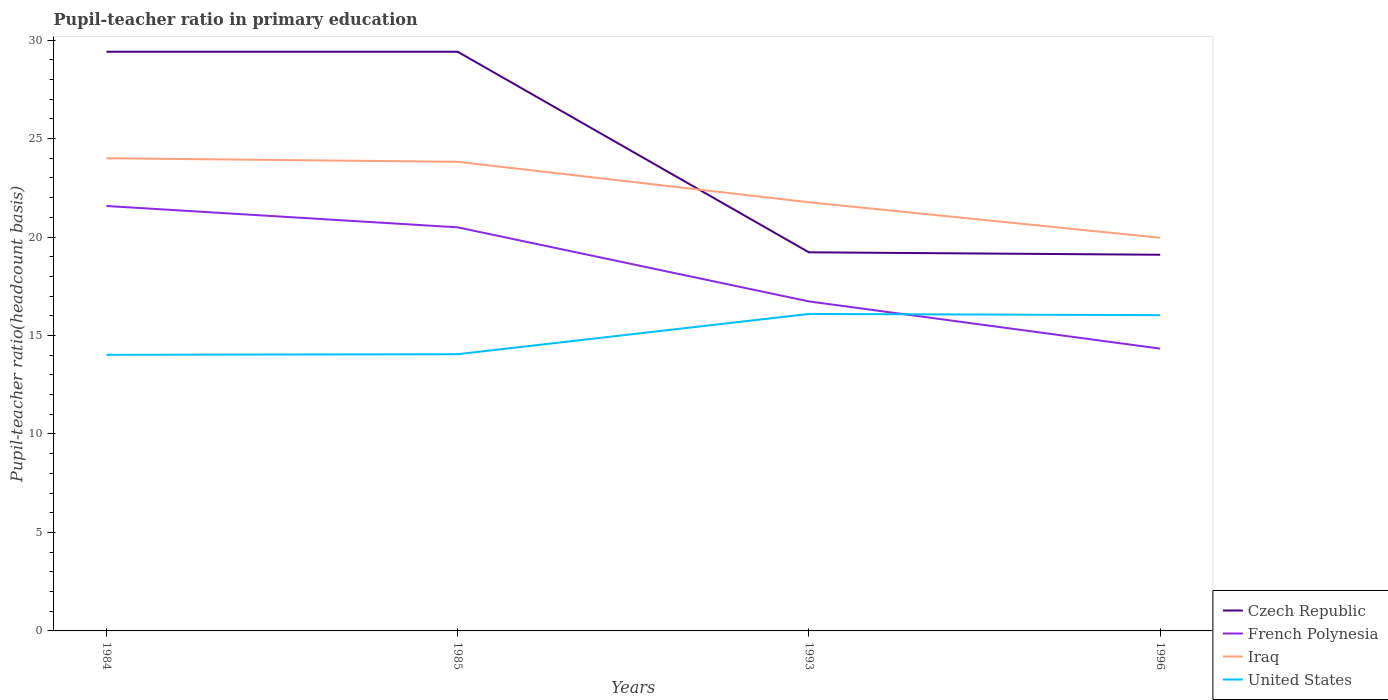Does the line corresponding to French Polynesia intersect with the line corresponding to Iraq?
Provide a short and direct response. No. Across all years, what is the maximum pupil-teacher ratio in primary education in United States?
Offer a very short reply. 14.02. What is the total pupil-teacher ratio in primary education in French Polynesia in the graph?
Offer a very short reply. 7.24. What is the difference between the highest and the second highest pupil-teacher ratio in primary education in Czech Republic?
Ensure brevity in your answer.  10.31. What is the difference between the highest and the lowest pupil-teacher ratio in primary education in United States?
Keep it short and to the point. 2. How many lines are there?
Provide a succinct answer. 4. How many years are there in the graph?
Give a very brief answer. 4. What is the difference between two consecutive major ticks on the Y-axis?
Provide a short and direct response. 5. Are the values on the major ticks of Y-axis written in scientific E-notation?
Your answer should be compact. No. Does the graph contain any zero values?
Offer a very short reply. No. Where does the legend appear in the graph?
Your response must be concise. Bottom right. What is the title of the graph?
Provide a succinct answer. Pupil-teacher ratio in primary education. Does "China" appear as one of the legend labels in the graph?
Your answer should be compact. No. What is the label or title of the X-axis?
Make the answer very short. Years. What is the label or title of the Y-axis?
Provide a succinct answer. Pupil-teacher ratio(headcount basis). What is the Pupil-teacher ratio(headcount basis) of Czech Republic in 1984?
Your answer should be compact. 29.41. What is the Pupil-teacher ratio(headcount basis) of French Polynesia in 1984?
Provide a succinct answer. 21.58. What is the Pupil-teacher ratio(headcount basis) of Iraq in 1984?
Make the answer very short. 24. What is the Pupil-teacher ratio(headcount basis) in United States in 1984?
Offer a terse response. 14.02. What is the Pupil-teacher ratio(headcount basis) of Czech Republic in 1985?
Make the answer very short. 29.41. What is the Pupil-teacher ratio(headcount basis) of French Polynesia in 1985?
Provide a succinct answer. 20.49. What is the Pupil-teacher ratio(headcount basis) of Iraq in 1985?
Give a very brief answer. 23.82. What is the Pupil-teacher ratio(headcount basis) of United States in 1985?
Your response must be concise. 14.05. What is the Pupil-teacher ratio(headcount basis) of Czech Republic in 1993?
Offer a very short reply. 19.23. What is the Pupil-teacher ratio(headcount basis) of French Polynesia in 1993?
Offer a very short reply. 16.73. What is the Pupil-teacher ratio(headcount basis) in Iraq in 1993?
Ensure brevity in your answer.  21.77. What is the Pupil-teacher ratio(headcount basis) of United States in 1993?
Offer a very short reply. 16.1. What is the Pupil-teacher ratio(headcount basis) in Czech Republic in 1996?
Give a very brief answer. 19.1. What is the Pupil-teacher ratio(headcount basis) in French Polynesia in 1996?
Your answer should be compact. 14.33. What is the Pupil-teacher ratio(headcount basis) in Iraq in 1996?
Your response must be concise. 19.96. What is the Pupil-teacher ratio(headcount basis) of United States in 1996?
Make the answer very short. 16.03. Across all years, what is the maximum Pupil-teacher ratio(headcount basis) of Czech Republic?
Ensure brevity in your answer.  29.41. Across all years, what is the maximum Pupil-teacher ratio(headcount basis) of French Polynesia?
Make the answer very short. 21.58. Across all years, what is the maximum Pupil-teacher ratio(headcount basis) in Iraq?
Your response must be concise. 24. Across all years, what is the maximum Pupil-teacher ratio(headcount basis) in United States?
Make the answer very short. 16.1. Across all years, what is the minimum Pupil-teacher ratio(headcount basis) in Czech Republic?
Provide a succinct answer. 19.1. Across all years, what is the minimum Pupil-teacher ratio(headcount basis) of French Polynesia?
Ensure brevity in your answer.  14.33. Across all years, what is the minimum Pupil-teacher ratio(headcount basis) in Iraq?
Your answer should be compact. 19.96. Across all years, what is the minimum Pupil-teacher ratio(headcount basis) of United States?
Ensure brevity in your answer.  14.02. What is the total Pupil-teacher ratio(headcount basis) of Czech Republic in the graph?
Ensure brevity in your answer.  97.15. What is the total Pupil-teacher ratio(headcount basis) of French Polynesia in the graph?
Your response must be concise. 73.14. What is the total Pupil-teacher ratio(headcount basis) in Iraq in the graph?
Your response must be concise. 89.56. What is the total Pupil-teacher ratio(headcount basis) in United States in the graph?
Your answer should be very brief. 60.2. What is the difference between the Pupil-teacher ratio(headcount basis) of Czech Republic in 1984 and that in 1985?
Provide a short and direct response. 0. What is the difference between the Pupil-teacher ratio(headcount basis) in French Polynesia in 1984 and that in 1985?
Ensure brevity in your answer.  1.08. What is the difference between the Pupil-teacher ratio(headcount basis) of Iraq in 1984 and that in 1985?
Your answer should be very brief. 0.18. What is the difference between the Pupil-teacher ratio(headcount basis) of United States in 1984 and that in 1985?
Make the answer very short. -0.03. What is the difference between the Pupil-teacher ratio(headcount basis) in Czech Republic in 1984 and that in 1993?
Keep it short and to the point. 10.19. What is the difference between the Pupil-teacher ratio(headcount basis) in French Polynesia in 1984 and that in 1993?
Ensure brevity in your answer.  4.85. What is the difference between the Pupil-teacher ratio(headcount basis) of Iraq in 1984 and that in 1993?
Keep it short and to the point. 2.23. What is the difference between the Pupil-teacher ratio(headcount basis) in United States in 1984 and that in 1993?
Ensure brevity in your answer.  -2.08. What is the difference between the Pupil-teacher ratio(headcount basis) in Czech Republic in 1984 and that in 1996?
Your answer should be compact. 10.31. What is the difference between the Pupil-teacher ratio(headcount basis) in French Polynesia in 1984 and that in 1996?
Keep it short and to the point. 7.24. What is the difference between the Pupil-teacher ratio(headcount basis) of Iraq in 1984 and that in 1996?
Offer a very short reply. 4.04. What is the difference between the Pupil-teacher ratio(headcount basis) of United States in 1984 and that in 1996?
Give a very brief answer. -2.01. What is the difference between the Pupil-teacher ratio(headcount basis) of Czech Republic in 1985 and that in 1993?
Your answer should be very brief. 10.19. What is the difference between the Pupil-teacher ratio(headcount basis) of French Polynesia in 1985 and that in 1993?
Ensure brevity in your answer.  3.76. What is the difference between the Pupil-teacher ratio(headcount basis) of Iraq in 1985 and that in 1993?
Your response must be concise. 2.05. What is the difference between the Pupil-teacher ratio(headcount basis) in United States in 1985 and that in 1993?
Your response must be concise. -2.05. What is the difference between the Pupil-teacher ratio(headcount basis) of Czech Republic in 1985 and that in 1996?
Keep it short and to the point. 10.31. What is the difference between the Pupil-teacher ratio(headcount basis) in French Polynesia in 1985 and that in 1996?
Provide a succinct answer. 6.16. What is the difference between the Pupil-teacher ratio(headcount basis) of Iraq in 1985 and that in 1996?
Keep it short and to the point. 3.86. What is the difference between the Pupil-teacher ratio(headcount basis) of United States in 1985 and that in 1996?
Make the answer very short. -1.98. What is the difference between the Pupil-teacher ratio(headcount basis) in Czech Republic in 1993 and that in 1996?
Your response must be concise. 0.12. What is the difference between the Pupil-teacher ratio(headcount basis) of French Polynesia in 1993 and that in 1996?
Your answer should be very brief. 2.4. What is the difference between the Pupil-teacher ratio(headcount basis) in Iraq in 1993 and that in 1996?
Provide a short and direct response. 1.8. What is the difference between the Pupil-teacher ratio(headcount basis) in United States in 1993 and that in 1996?
Provide a succinct answer. 0.06. What is the difference between the Pupil-teacher ratio(headcount basis) in Czech Republic in 1984 and the Pupil-teacher ratio(headcount basis) in French Polynesia in 1985?
Your response must be concise. 8.92. What is the difference between the Pupil-teacher ratio(headcount basis) of Czech Republic in 1984 and the Pupil-teacher ratio(headcount basis) of Iraq in 1985?
Your answer should be compact. 5.59. What is the difference between the Pupil-teacher ratio(headcount basis) of Czech Republic in 1984 and the Pupil-teacher ratio(headcount basis) of United States in 1985?
Provide a short and direct response. 15.36. What is the difference between the Pupil-teacher ratio(headcount basis) in French Polynesia in 1984 and the Pupil-teacher ratio(headcount basis) in Iraq in 1985?
Make the answer very short. -2.24. What is the difference between the Pupil-teacher ratio(headcount basis) in French Polynesia in 1984 and the Pupil-teacher ratio(headcount basis) in United States in 1985?
Provide a succinct answer. 7.53. What is the difference between the Pupil-teacher ratio(headcount basis) of Iraq in 1984 and the Pupil-teacher ratio(headcount basis) of United States in 1985?
Provide a succinct answer. 9.95. What is the difference between the Pupil-teacher ratio(headcount basis) of Czech Republic in 1984 and the Pupil-teacher ratio(headcount basis) of French Polynesia in 1993?
Give a very brief answer. 12.68. What is the difference between the Pupil-teacher ratio(headcount basis) of Czech Republic in 1984 and the Pupil-teacher ratio(headcount basis) of Iraq in 1993?
Ensure brevity in your answer.  7.64. What is the difference between the Pupil-teacher ratio(headcount basis) of Czech Republic in 1984 and the Pupil-teacher ratio(headcount basis) of United States in 1993?
Offer a terse response. 13.32. What is the difference between the Pupil-teacher ratio(headcount basis) in French Polynesia in 1984 and the Pupil-teacher ratio(headcount basis) in Iraq in 1993?
Make the answer very short. -0.19. What is the difference between the Pupil-teacher ratio(headcount basis) of French Polynesia in 1984 and the Pupil-teacher ratio(headcount basis) of United States in 1993?
Your answer should be very brief. 5.48. What is the difference between the Pupil-teacher ratio(headcount basis) in Iraq in 1984 and the Pupil-teacher ratio(headcount basis) in United States in 1993?
Offer a very short reply. 7.91. What is the difference between the Pupil-teacher ratio(headcount basis) of Czech Republic in 1984 and the Pupil-teacher ratio(headcount basis) of French Polynesia in 1996?
Keep it short and to the point. 15.08. What is the difference between the Pupil-teacher ratio(headcount basis) in Czech Republic in 1984 and the Pupil-teacher ratio(headcount basis) in Iraq in 1996?
Make the answer very short. 9.45. What is the difference between the Pupil-teacher ratio(headcount basis) of Czech Republic in 1984 and the Pupil-teacher ratio(headcount basis) of United States in 1996?
Offer a terse response. 13.38. What is the difference between the Pupil-teacher ratio(headcount basis) of French Polynesia in 1984 and the Pupil-teacher ratio(headcount basis) of Iraq in 1996?
Your answer should be compact. 1.61. What is the difference between the Pupil-teacher ratio(headcount basis) in French Polynesia in 1984 and the Pupil-teacher ratio(headcount basis) in United States in 1996?
Make the answer very short. 5.54. What is the difference between the Pupil-teacher ratio(headcount basis) in Iraq in 1984 and the Pupil-teacher ratio(headcount basis) in United States in 1996?
Offer a terse response. 7.97. What is the difference between the Pupil-teacher ratio(headcount basis) in Czech Republic in 1985 and the Pupil-teacher ratio(headcount basis) in French Polynesia in 1993?
Your answer should be compact. 12.68. What is the difference between the Pupil-teacher ratio(headcount basis) in Czech Republic in 1985 and the Pupil-teacher ratio(headcount basis) in Iraq in 1993?
Ensure brevity in your answer.  7.64. What is the difference between the Pupil-teacher ratio(headcount basis) of Czech Republic in 1985 and the Pupil-teacher ratio(headcount basis) of United States in 1993?
Keep it short and to the point. 13.31. What is the difference between the Pupil-teacher ratio(headcount basis) in French Polynesia in 1985 and the Pupil-teacher ratio(headcount basis) in Iraq in 1993?
Ensure brevity in your answer.  -1.27. What is the difference between the Pupil-teacher ratio(headcount basis) in French Polynesia in 1985 and the Pupil-teacher ratio(headcount basis) in United States in 1993?
Provide a succinct answer. 4.4. What is the difference between the Pupil-teacher ratio(headcount basis) in Iraq in 1985 and the Pupil-teacher ratio(headcount basis) in United States in 1993?
Provide a short and direct response. 7.73. What is the difference between the Pupil-teacher ratio(headcount basis) of Czech Republic in 1985 and the Pupil-teacher ratio(headcount basis) of French Polynesia in 1996?
Keep it short and to the point. 15.08. What is the difference between the Pupil-teacher ratio(headcount basis) of Czech Republic in 1985 and the Pupil-teacher ratio(headcount basis) of Iraq in 1996?
Ensure brevity in your answer.  9.45. What is the difference between the Pupil-teacher ratio(headcount basis) of Czech Republic in 1985 and the Pupil-teacher ratio(headcount basis) of United States in 1996?
Your answer should be compact. 13.38. What is the difference between the Pupil-teacher ratio(headcount basis) of French Polynesia in 1985 and the Pupil-teacher ratio(headcount basis) of Iraq in 1996?
Ensure brevity in your answer.  0.53. What is the difference between the Pupil-teacher ratio(headcount basis) of French Polynesia in 1985 and the Pupil-teacher ratio(headcount basis) of United States in 1996?
Make the answer very short. 4.46. What is the difference between the Pupil-teacher ratio(headcount basis) of Iraq in 1985 and the Pupil-teacher ratio(headcount basis) of United States in 1996?
Your answer should be compact. 7.79. What is the difference between the Pupil-teacher ratio(headcount basis) in Czech Republic in 1993 and the Pupil-teacher ratio(headcount basis) in French Polynesia in 1996?
Your answer should be compact. 4.89. What is the difference between the Pupil-teacher ratio(headcount basis) of Czech Republic in 1993 and the Pupil-teacher ratio(headcount basis) of Iraq in 1996?
Provide a short and direct response. -0.74. What is the difference between the Pupil-teacher ratio(headcount basis) in Czech Republic in 1993 and the Pupil-teacher ratio(headcount basis) in United States in 1996?
Provide a succinct answer. 3.19. What is the difference between the Pupil-teacher ratio(headcount basis) of French Polynesia in 1993 and the Pupil-teacher ratio(headcount basis) of Iraq in 1996?
Provide a short and direct response. -3.23. What is the difference between the Pupil-teacher ratio(headcount basis) in French Polynesia in 1993 and the Pupil-teacher ratio(headcount basis) in United States in 1996?
Provide a short and direct response. 0.7. What is the difference between the Pupil-teacher ratio(headcount basis) in Iraq in 1993 and the Pupil-teacher ratio(headcount basis) in United States in 1996?
Your response must be concise. 5.73. What is the average Pupil-teacher ratio(headcount basis) in Czech Republic per year?
Ensure brevity in your answer.  24.29. What is the average Pupil-teacher ratio(headcount basis) in French Polynesia per year?
Give a very brief answer. 18.29. What is the average Pupil-teacher ratio(headcount basis) in Iraq per year?
Your answer should be compact. 22.39. What is the average Pupil-teacher ratio(headcount basis) of United States per year?
Keep it short and to the point. 15.05. In the year 1984, what is the difference between the Pupil-teacher ratio(headcount basis) in Czech Republic and Pupil-teacher ratio(headcount basis) in French Polynesia?
Your answer should be compact. 7.83. In the year 1984, what is the difference between the Pupil-teacher ratio(headcount basis) of Czech Republic and Pupil-teacher ratio(headcount basis) of Iraq?
Offer a very short reply. 5.41. In the year 1984, what is the difference between the Pupil-teacher ratio(headcount basis) in Czech Republic and Pupil-teacher ratio(headcount basis) in United States?
Keep it short and to the point. 15.39. In the year 1984, what is the difference between the Pupil-teacher ratio(headcount basis) in French Polynesia and Pupil-teacher ratio(headcount basis) in Iraq?
Give a very brief answer. -2.42. In the year 1984, what is the difference between the Pupil-teacher ratio(headcount basis) in French Polynesia and Pupil-teacher ratio(headcount basis) in United States?
Your answer should be very brief. 7.56. In the year 1984, what is the difference between the Pupil-teacher ratio(headcount basis) in Iraq and Pupil-teacher ratio(headcount basis) in United States?
Offer a terse response. 9.98. In the year 1985, what is the difference between the Pupil-teacher ratio(headcount basis) of Czech Republic and Pupil-teacher ratio(headcount basis) of French Polynesia?
Provide a succinct answer. 8.92. In the year 1985, what is the difference between the Pupil-teacher ratio(headcount basis) in Czech Republic and Pupil-teacher ratio(headcount basis) in Iraq?
Offer a very short reply. 5.59. In the year 1985, what is the difference between the Pupil-teacher ratio(headcount basis) of Czech Republic and Pupil-teacher ratio(headcount basis) of United States?
Make the answer very short. 15.36. In the year 1985, what is the difference between the Pupil-teacher ratio(headcount basis) of French Polynesia and Pupil-teacher ratio(headcount basis) of Iraq?
Your answer should be compact. -3.33. In the year 1985, what is the difference between the Pupil-teacher ratio(headcount basis) in French Polynesia and Pupil-teacher ratio(headcount basis) in United States?
Give a very brief answer. 6.44. In the year 1985, what is the difference between the Pupil-teacher ratio(headcount basis) of Iraq and Pupil-teacher ratio(headcount basis) of United States?
Your answer should be very brief. 9.77. In the year 1993, what is the difference between the Pupil-teacher ratio(headcount basis) of Czech Republic and Pupil-teacher ratio(headcount basis) of French Polynesia?
Your response must be concise. 2.49. In the year 1993, what is the difference between the Pupil-teacher ratio(headcount basis) in Czech Republic and Pupil-teacher ratio(headcount basis) in Iraq?
Give a very brief answer. -2.54. In the year 1993, what is the difference between the Pupil-teacher ratio(headcount basis) in Czech Republic and Pupil-teacher ratio(headcount basis) in United States?
Provide a short and direct response. 3.13. In the year 1993, what is the difference between the Pupil-teacher ratio(headcount basis) of French Polynesia and Pupil-teacher ratio(headcount basis) of Iraq?
Keep it short and to the point. -5.03. In the year 1993, what is the difference between the Pupil-teacher ratio(headcount basis) of French Polynesia and Pupil-teacher ratio(headcount basis) of United States?
Your answer should be compact. 0.64. In the year 1993, what is the difference between the Pupil-teacher ratio(headcount basis) of Iraq and Pupil-teacher ratio(headcount basis) of United States?
Ensure brevity in your answer.  5.67. In the year 1996, what is the difference between the Pupil-teacher ratio(headcount basis) in Czech Republic and Pupil-teacher ratio(headcount basis) in French Polynesia?
Keep it short and to the point. 4.77. In the year 1996, what is the difference between the Pupil-teacher ratio(headcount basis) of Czech Republic and Pupil-teacher ratio(headcount basis) of Iraq?
Make the answer very short. -0.86. In the year 1996, what is the difference between the Pupil-teacher ratio(headcount basis) of Czech Republic and Pupil-teacher ratio(headcount basis) of United States?
Your answer should be compact. 3.07. In the year 1996, what is the difference between the Pupil-teacher ratio(headcount basis) of French Polynesia and Pupil-teacher ratio(headcount basis) of Iraq?
Make the answer very short. -5.63. In the year 1996, what is the difference between the Pupil-teacher ratio(headcount basis) of French Polynesia and Pupil-teacher ratio(headcount basis) of United States?
Provide a short and direct response. -1.7. In the year 1996, what is the difference between the Pupil-teacher ratio(headcount basis) in Iraq and Pupil-teacher ratio(headcount basis) in United States?
Provide a succinct answer. 3.93. What is the ratio of the Pupil-teacher ratio(headcount basis) in Czech Republic in 1984 to that in 1985?
Offer a very short reply. 1. What is the ratio of the Pupil-teacher ratio(headcount basis) of French Polynesia in 1984 to that in 1985?
Make the answer very short. 1.05. What is the ratio of the Pupil-teacher ratio(headcount basis) of Iraq in 1984 to that in 1985?
Give a very brief answer. 1.01. What is the ratio of the Pupil-teacher ratio(headcount basis) in United States in 1984 to that in 1985?
Ensure brevity in your answer.  1. What is the ratio of the Pupil-teacher ratio(headcount basis) in Czech Republic in 1984 to that in 1993?
Provide a succinct answer. 1.53. What is the ratio of the Pupil-teacher ratio(headcount basis) in French Polynesia in 1984 to that in 1993?
Offer a terse response. 1.29. What is the ratio of the Pupil-teacher ratio(headcount basis) of Iraq in 1984 to that in 1993?
Make the answer very short. 1.1. What is the ratio of the Pupil-teacher ratio(headcount basis) of United States in 1984 to that in 1993?
Your answer should be compact. 0.87. What is the ratio of the Pupil-teacher ratio(headcount basis) in Czech Republic in 1984 to that in 1996?
Your answer should be very brief. 1.54. What is the ratio of the Pupil-teacher ratio(headcount basis) in French Polynesia in 1984 to that in 1996?
Ensure brevity in your answer.  1.51. What is the ratio of the Pupil-teacher ratio(headcount basis) in Iraq in 1984 to that in 1996?
Provide a short and direct response. 1.2. What is the ratio of the Pupil-teacher ratio(headcount basis) of United States in 1984 to that in 1996?
Your answer should be compact. 0.87. What is the ratio of the Pupil-teacher ratio(headcount basis) in Czech Republic in 1985 to that in 1993?
Offer a very short reply. 1.53. What is the ratio of the Pupil-teacher ratio(headcount basis) in French Polynesia in 1985 to that in 1993?
Your answer should be very brief. 1.22. What is the ratio of the Pupil-teacher ratio(headcount basis) in Iraq in 1985 to that in 1993?
Give a very brief answer. 1.09. What is the ratio of the Pupil-teacher ratio(headcount basis) in United States in 1985 to that in 1993?
Offer a very short reply. 0.87. What is the ratio of the Pupil-teacher ratio(headcount basis) in Czech Republic in 1985 to that in 1996?
Provide a succinct answer. 1.54. What is the ratio of the Pupil-teacher ratio(headcount basis) in French Polynesia in 1985 to that in 1996?
Your response must be concise. 1.43. What is the ratio of the Pupil-teacher ratio(headcount basis) in Iraq in 1985 to that in 1996?
Give a very brief answer. 1.19. What is the ratio of the Pupil-teacher ratio(headcount basis) of United States in 1985 to that in 1996?
Provide a succinct answer. 0.88. What is the ratio of the Pupil-teacher ratio(headcount basis) in French Polynesia in 1993 to that in 1996?
Your answer should be compact. 1.17. What is the ratio of the Pupil-teacher ratio(headcount basis) in Iraq in 1993 to that in 1996?
Provide a short and direct response. 1.09. What is the ratio of the Pupil-teacher ratio(headcount basis) of United States in 1993 to that in 1996?
Your answer should be very brief. 1. What is the difference between the highest and the second highest Pupil-teacher ratio(headcount basis) of Czech Republic?
Your answer should be very brief. 0. What is the difference between the highest and the second highest Pupil-teacher ratio(headcount basis) in French Polynesia?
Provide a short and direct response. 1.08. What is the difference between the highest and the second highest Pupil-teacher ratio(headcount basis) of Iraq?
Your answer should be compact. 0.18. What is the difference between the highest and the second highest Pupil-teacher ratio(headcount basis) in United States?
Offer a terse response. 0.06. What is the difference between the highest and the lowest Pupil-teacher ratio(headcount basis) of Czech Republic?
Make the answer very short. 10.31. What is the difference between the highest and the lowest Pupil-teacher ratio(headcount basis) in French Polynesia?
Your answer should be compact. 7.24. What is the difference between the highest and the lowest Pupil-teacher ratio(headcount basis) in Iraq?
Your response must be concise. 4.04. What is the difference between the highest and the lowest Pupil-teacher ratio(headcount basis) of United States?
Ensure brevity in your answer.  2.08. 